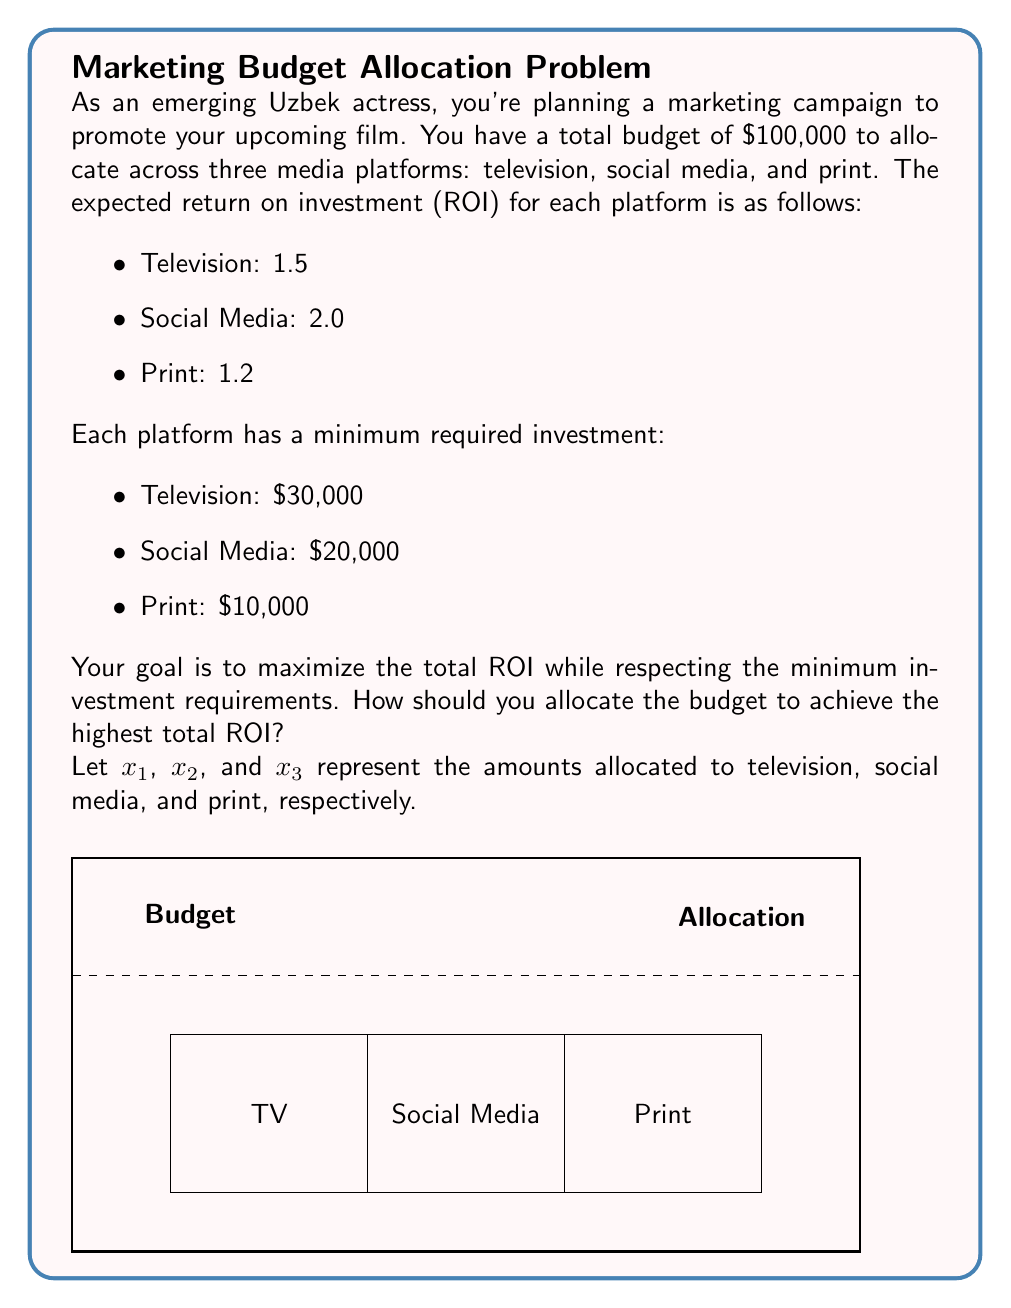Teach me how to tackle this problem. Let's approach this problem using linear programming:

1) Objective function: Maximize total ROI
   $$\text{Maximize } Z = 1.5x_1 + 2.0x_2 + 1.2x_3$$

2) Constraints:
   a) Total budget constraint:
      $$x_1 + x_2 + x_3 \leq 100,000$$
   b) Minimum investment constraints:
      $$x_1 \geq 30,000$$
      $$x_2 \geq 20,000$$
      $$x_3 \geq 10,000$$
   c) Non-negativity constraints:
      $$x_1, x_2, x_3 \geq 0$$

3) Solving the linear programming problem:
   Given the constraints, we can deduce that:
   - We must allocate at least $60,000 to meet minimum requirements
   - We have $40,000 left to allocate optimally

4) Since social media has the highest ROI (2.0), we should allocate the remaining $40,000 to social media:
   $$x_1 = 30,000$$
   $$x_2 = 60,000$$
   $$x_3 = 10,000$$

5) Verify that this solution satisfies all constraints:
   - Total budget: $30,000 + 60,000 + 10,000 = 100,000$
   - All minimum investment requirements are met
   - All amounts are non-negative

6) Calculate the total ROI:
   $$Z = 1.5(30,000) + 2.0(60,000) + 1.2(10,000) = 177,000$$

Therefore, the optimal allocation is $30,000 for TV, $60,000 for social media, and $10,000 for print, resulting in a total ROI of 177,000.
Answer: TV: $30,000, Social Media: $60,000, Print: $10,000 